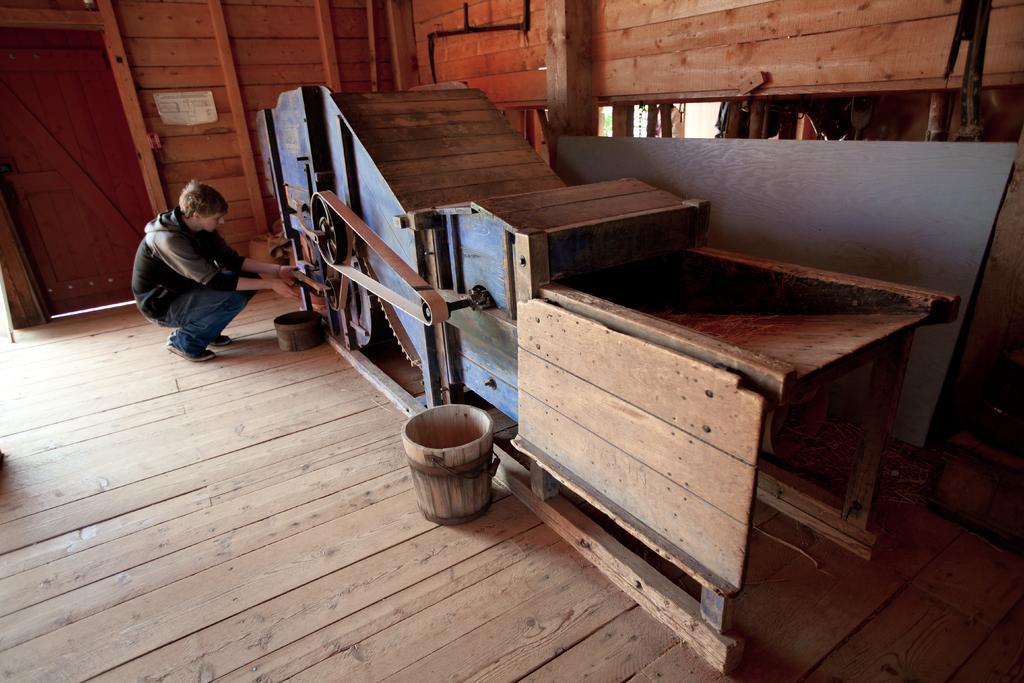Describe this image in one or two sentences. In this picture we can see buckets, wheel, door pipes and a person on the floor and in the background we can see a poster on the wall. 